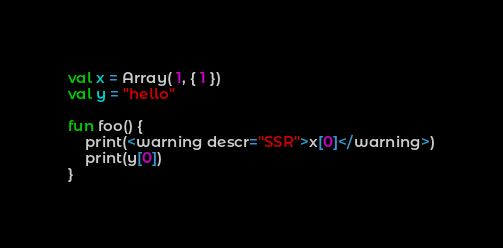<code> <loc_0><loc_0><loc_500><loc_500><_Kotlin_>val x = Array( 1, { 1 })
val y = "hello"

fun foo() {
    print(<warning descr="SSR">x[0]</warning>)
    print(y[0])
}</code> 